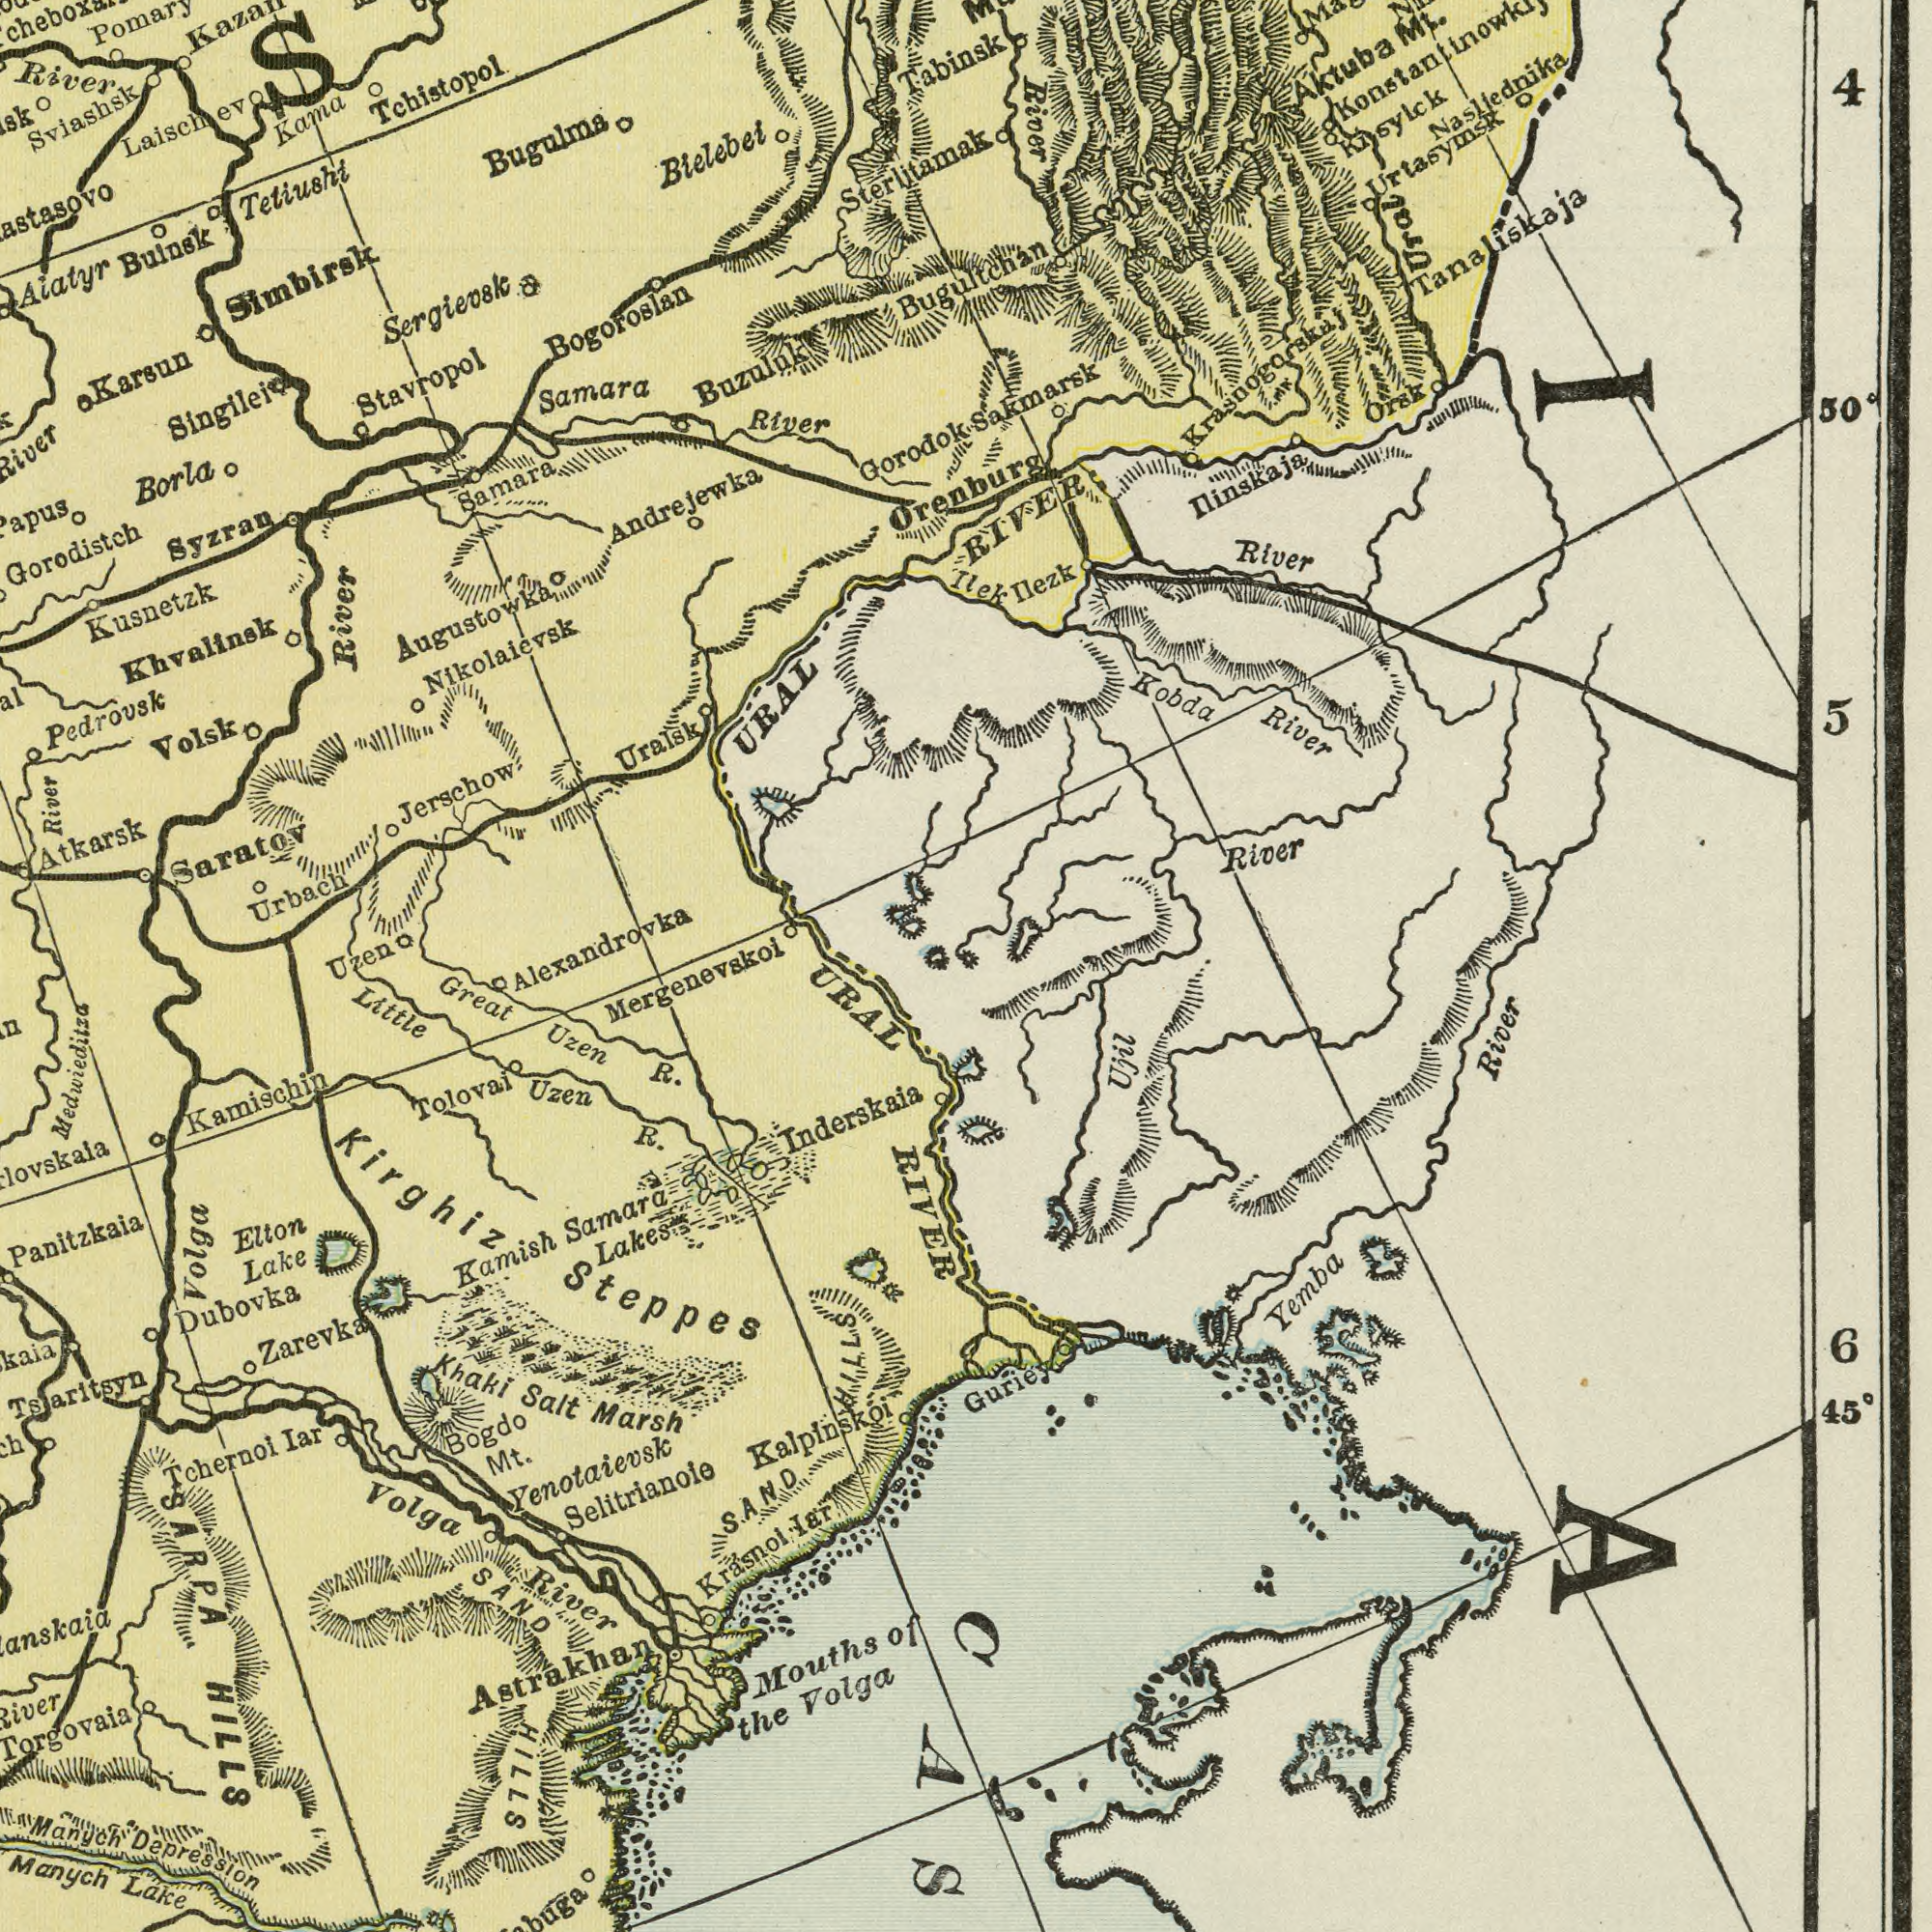What text is shown in the bottom-right quadrant? River Yemba 6 45<sup>0</sup> Ujil ###IA### Guriey What text appears in the top-right area of the image? RIVER River Nasliednika Sakmarsk River River Aktuba River Kobda Orsk Mt. Kisylck Ilezk 4 Urtasymsk Ilek Tanaliskaja 5 50<sup>0</sup> Ilinskaja Tabinsk Ural Bugultchan Krasnogorskaj Orenburg What text is visible in the upper-left corner? Gorodistch Saratov Sviashsk Kusnetzk Bogoroslan Atkarsk Stavropol Bugulma Bielebei Samara River Syzran Buzuluk Sergievsk Pedrovsk River Borla Samara Urbach Tetiushi Singilei Uralsk Kama Karsun Simbirsk River Jerschow River Andrejewka URAL Nikolaievsk River Pomary Bulnsk Aiatyr Augustowka Gorodok Khvalinsk Volsk Laischev Tchistopol Sterlitamak Uzen Alexandrovka What text can you see in the bottom-left section? Steppes Panitzkaia Volga Tsaritsyn Manych Inderskaia Kamischin Marsh Yenotaievsk Selitrianoie Torgovaia Tchernoi Khaki Volga River Lake Great Tolovai Depression Krasnol Lake R. Salt Iar Little R. Samara RIVER Dubovka Lakes Zarevka Uzen HILLS Bogdo HILLS Elton River SAND SARPA Iar Medwieditza Mt. Manych Uzen Astrakhan Kamish Kirghiz Mergenevskoi URAL Kalplnskoi SAND Mouths of the Volga HILLS 